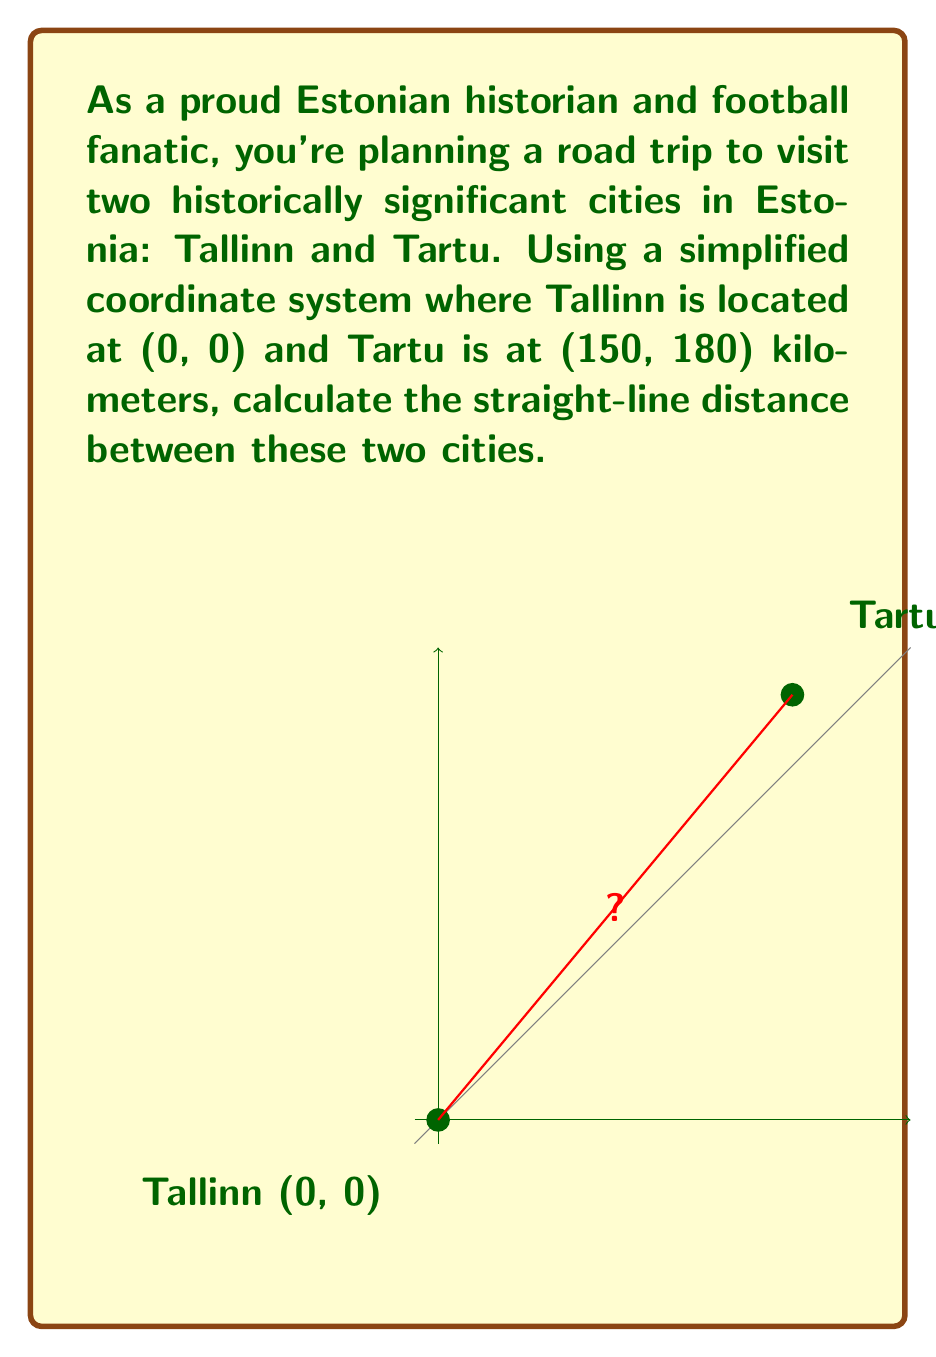Help me with this question. To find the straight-line distance between Tallinn and Tartu, we can use the distance formula derived from the Pythagorean theorem:

$$d = \sqrt{(x_2 - x_1)^2 + (y_2 - y_1)^2}$$

Where $(x_1, y_1)$ are the coordinates of Tallinn (0, 0) and $(x_2, y_2)$ are the coordinates of Tartu (150, 180).

Let's plug these values into the formula:

$$\begin{align}
d &= \sqrt{(150 - 0)^2 + (180 - 0)^2} \\
&= \sqrt{150^2 + 180^2} \\
&= \sqrt{22500 + 32400} \\
&= \sqrt{54900} \\
&\approx 234.31
\end{align}$$

Therefore, the straight-line distance between Tallinn and Tartu is approximately 234.31 kilometers.
Answer: $234.31$ km 